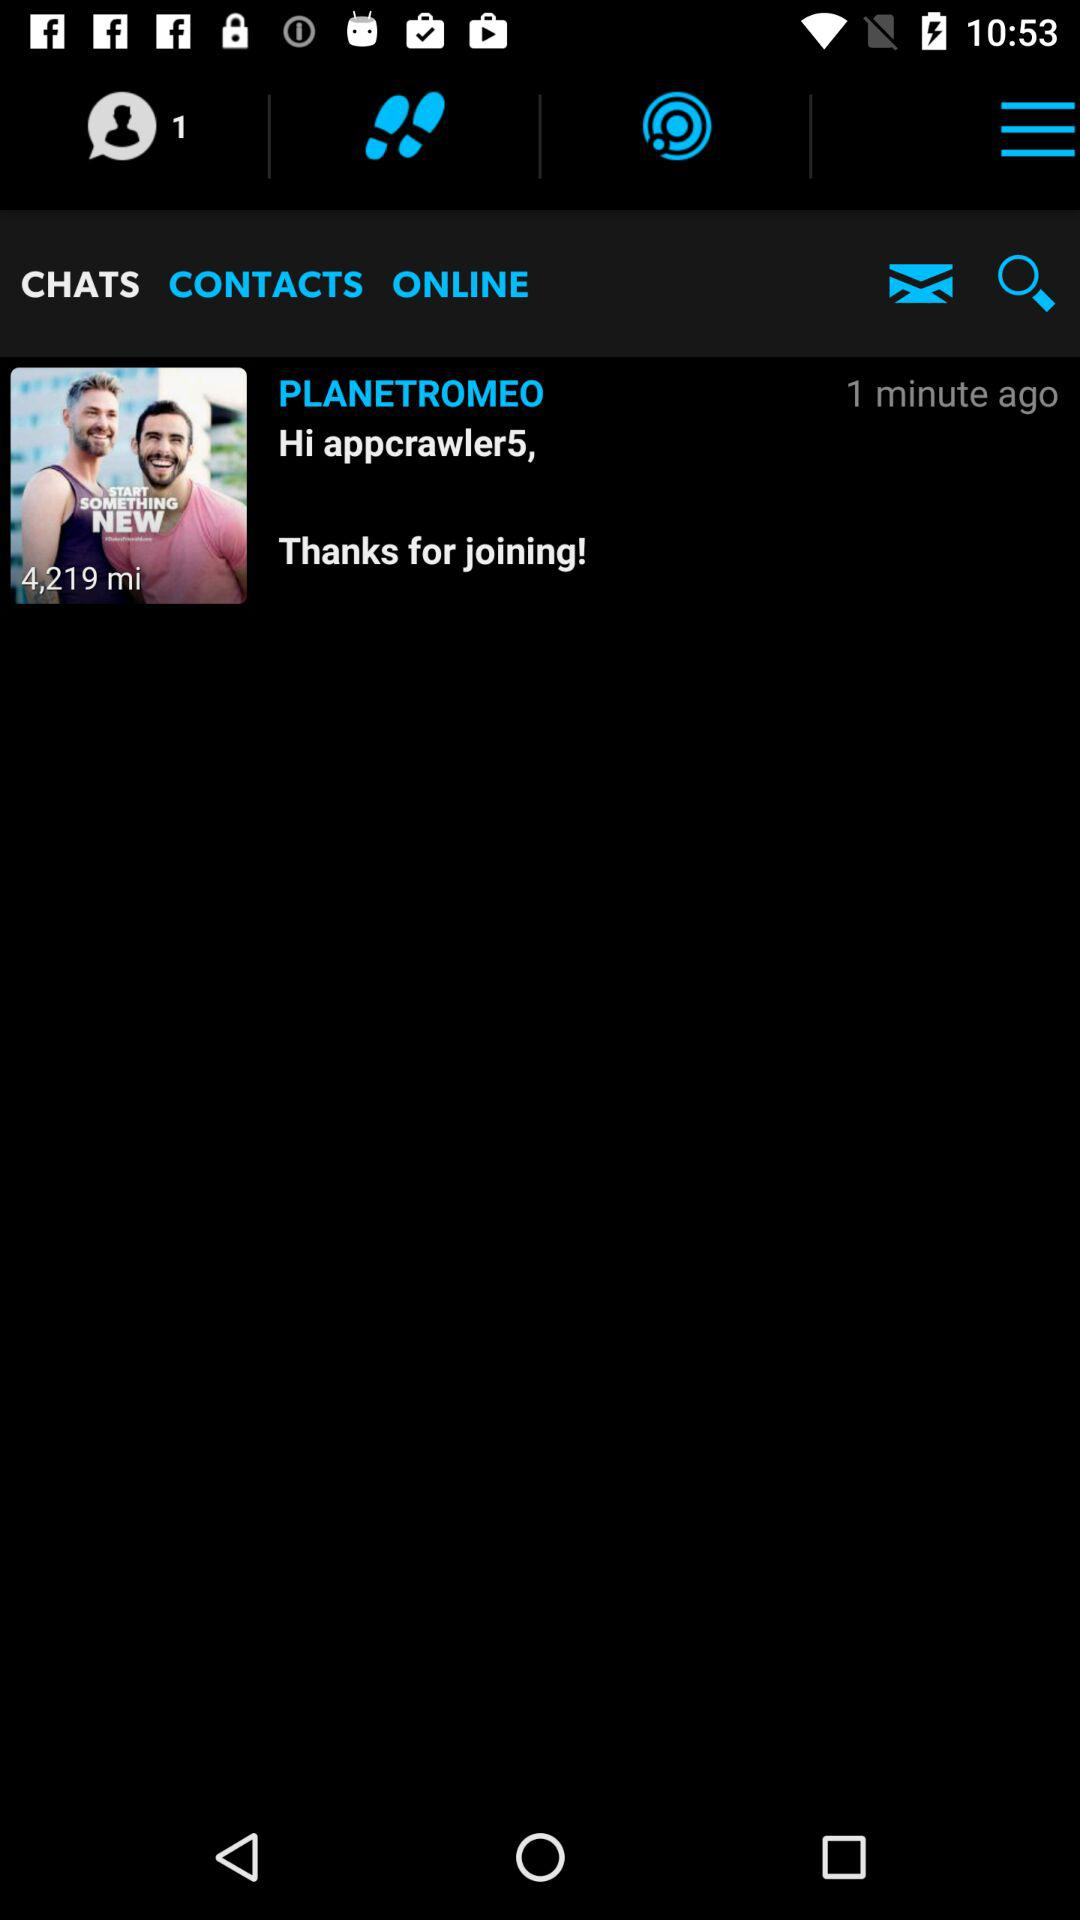What is the distance between the user and the person they are messaging?
Answer the question using a single word or phrase. 4,219 mi 